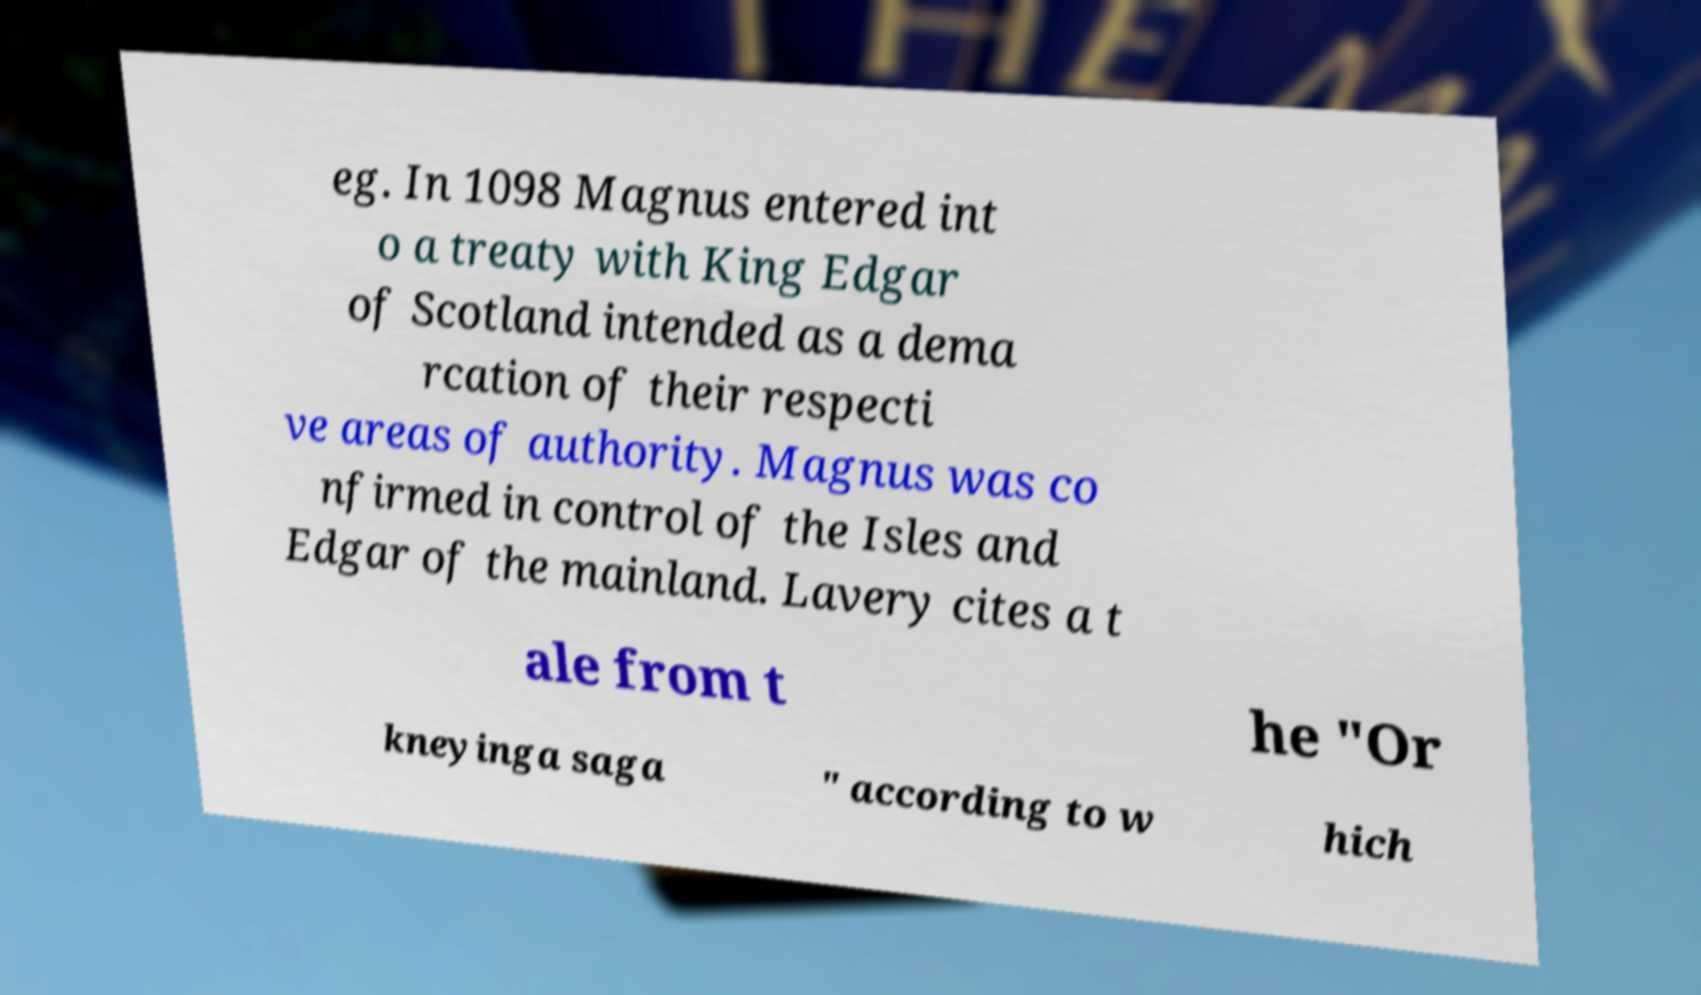Can you read and provide the text displayed in the image?This photo seems to have some interesting text. Can you extract and type it out for me? eg. In 1098 Magnus entered int o a treaty with King Edgar of Scotland intended as a dema rcation of their respecti ve areas of authority. Magnus was co nfirmed in control of the Isles and Edgar of the mainland. Lavery cites a t ale from t he "Or kneyinga saga " according to w hich 